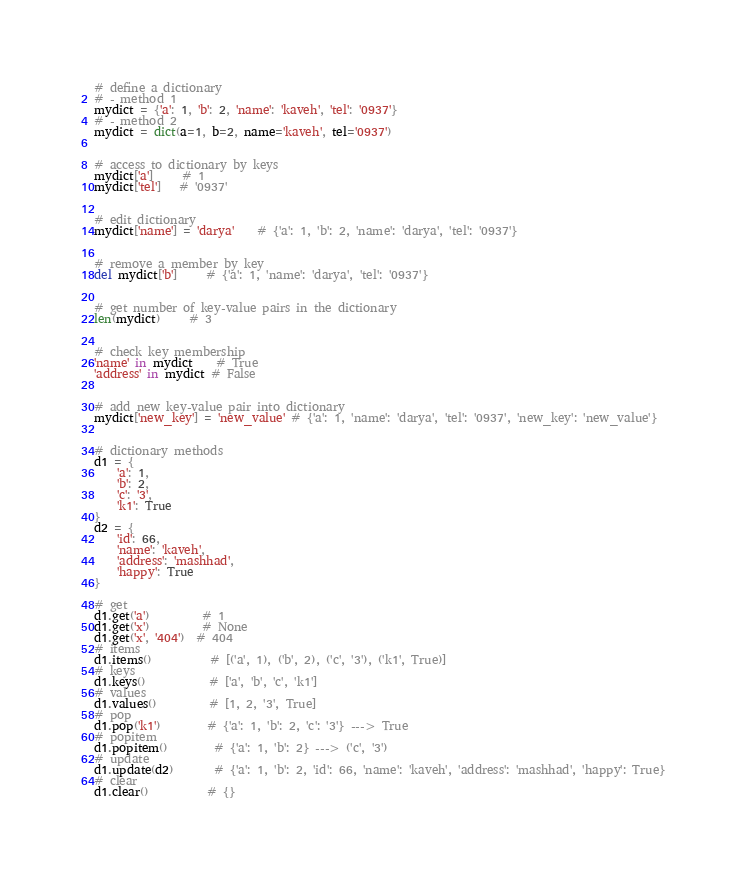<code> <loc_0><loc_0><loc_500><loc_500><_Python_># define a dictionary
# - method 1
mydict = {'a': 1, 'b': 2, 'name': 'kaveh', 'tel': '0937'}
# - method 2
mydict = dict(a=1, b=2, name='kaveh', tel='0937')


# access to dictionary by keys
mydict['a']     # 1
mydict['tel']   # '0937'


# edit dictionary
mydict['name'] = 'darya'    # {'a': 1, 'b': 2, 'name': 'darya', 'tel': '0937'}


# remove a member by key
del mydict['b']     # {'a': 1, 'name': 'darya', 'tel': '0937'}


# get number of key-value pairs in the dictionary
len(mydict)     # 3


# check key membership
'name' in mydict    # True
'address' in mydict # False


# add new key-value pair into dictionary
mydict['new_key'] = 'new_value' # {'a': 1, 'name': 'darya', 'tel': '0937', 'new_key': 'new_value'}


# dictionary methods
d1 = {
    'a': 1,
    'b': 2,
    'c': '3',
    'k1': True
}
d2 = {
    'id': 66,
    'name': 'kaveh',
    'address': 'mashhad',
    'happy': True
}

# get
d1.get('a')         # 1
d1.get('x')         # None
d1.get('x', '404')  # 404
# items
d1.items()          # [('a', 1), ('b', 2), ('c', '3'), ('k1', True)]
# keys
d1.keys()           # ['a', 'b', 'c', 'k1']
# values
d1.values()         # [1, 2, '3', True]
# pop
d1.pop('k1')        # {'a': 1, 'b': 2, 'c': '3'} ---> True
# popitem
d1.popitem()        # {'a': 1, 'b': 2} ---> ('c', '3')
# update
d1.update(d2)       # {'a': 1, 'b': 2, 'id': 66, 'name': 'kaveh', 'address': 'mashhad', 'happy': True}
# clear
d1.clear()          # {}
</code> 